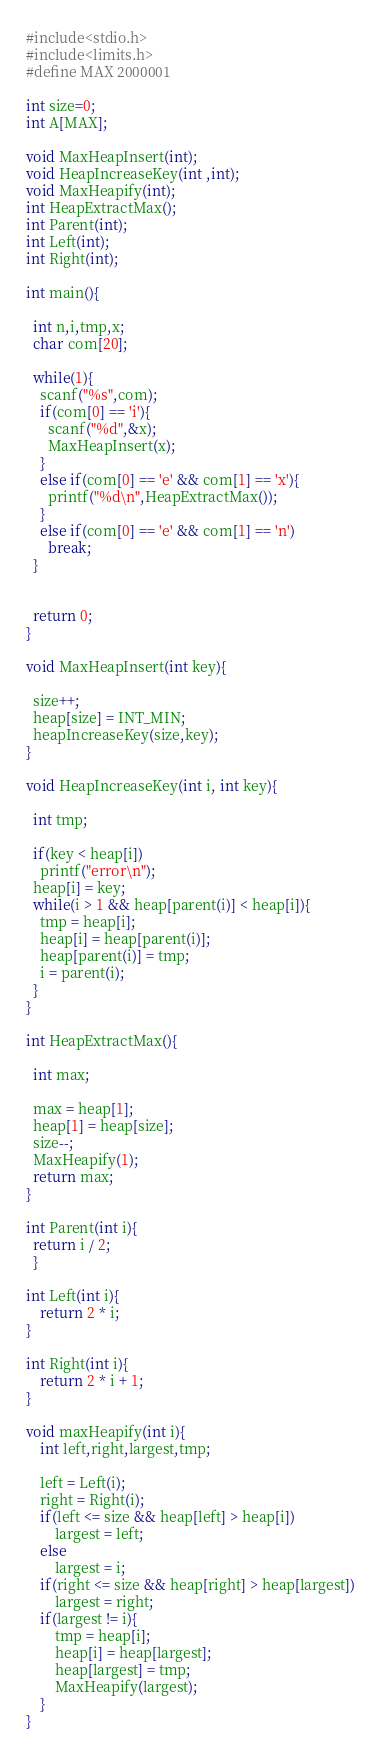<code> <loc_0><loc_0><loc_500><loc_500><_C_>#include<stdio.h>
#include<limits.h>
#define MAX 2000001
 
int size=0;
int A[MAX];
 
void MaxHeapInsert(int);
void HeapIncreaseKey(int ,int);
void MaxHeapify(int);
int HeapExtractMax();
int Parent(int);
int Left(int);
int Right(int);
 
int main(){
 
  int n,i,tmp,x;
  char com[20];
 
  while(1){
    scanf("%s",com);
    if(com[0] == 'i'){
      scanf("%d",&x);
      MaxHeapInsert(x);
    }
    else if(com[0] == 'e' && com[1] == 'x'){
      printf("%d\n",HeapExtractMax());
    }
    else if(com[0] == 'e' && com[1] == 'n')
      break;
  }
   
 
  return 0;
}
 
void MaxHeapInsert(int key){
 
  size++;
  heap[size] = INT_MIN;
  heapIncreaseKey(size,key);
}
 
void HeapIncreaseKey(int i, int key){
 
  int tmp;
 
  if(key < heap[i])
    printf("error\n");
  heap[i] = key;
  while(i > 1 && heap[parent(i)] < heap[i]){
    tmp = heap[i];
    heap[i] = heap[parent(i)];
    heap[parent(i)] = tmp;
    i = parent(i);
  }
}
 
int HeapExtractMax(){
 
  int max;
 
  max = heap[1];
  heap[1] = heap[size];
  size--;
  MaxHeapify(1);
  return max;
}
 
int Parent(int i){
  return i / 2;
  }
 
int Left(int i){
    return 2 * i;
}
  
int Right(int i){
    return 2 * i + 1;
}
 
void maxHeapify(int i){
    int left,right,largest,tmp;
  
    left = Left(i);
    right = Right(i);
    if(left <= size && heap[left] > heap[i])
        largest = left;
    else
        largest = i;
    if(right <= size && heap[right] > heap[largest])
        largest = right;
    if(largest != i){
        tmp = heap[i];
        heap[i] = heap[largest];
        heap[largest] = tmp;
        MaxHeapify(largest);
    }
}</code> 